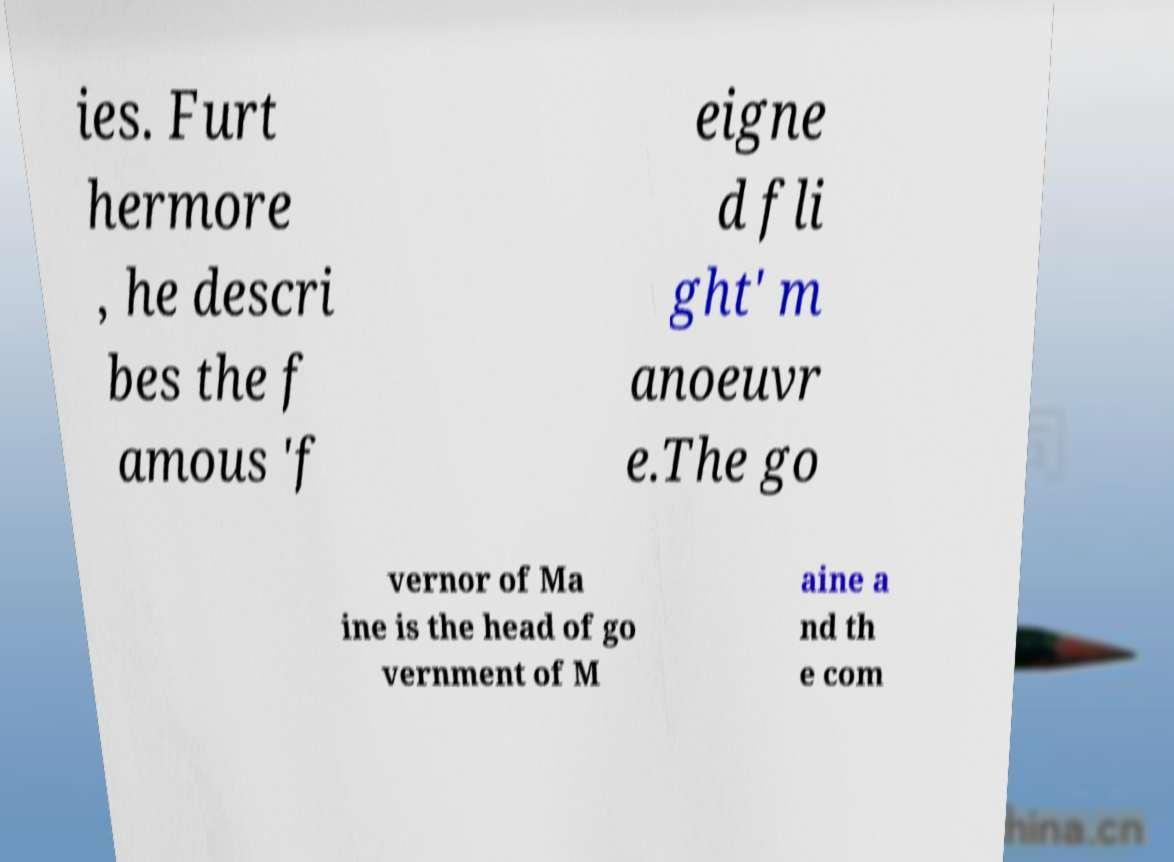Could you assist in decoding the text presented in this image and type it out clearly? ies. Furt hermore , he descri bes the f amous 'f eigne d fli ght' m anoeuvr e.The go vernor of Ma ine is the head of go vernment of M aine a nd th e com 